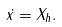Convert formula to latex. <formula><loc_0><loc_0><loc_500><loc_500>\dot { x } = X _ { h } .</formula> 